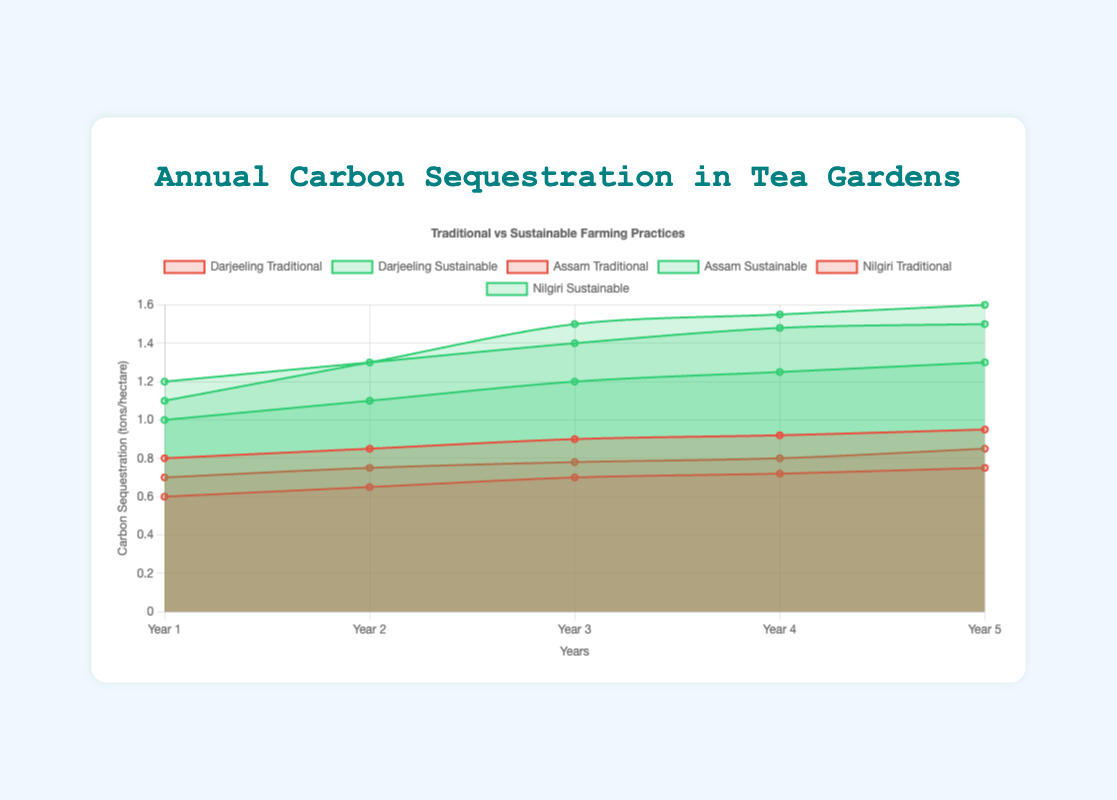What is the title of the chart? The title is displayed at the top of the chart, which reads "Annual Carbon Sequestration in Tea Gardens".
Answer: Annual Carbon Sequestration in Tea Gardens What does the y-axis represent? The label on the y-axis indicates it represents "Carbon Sequestration (tons/hectare)".
Answer: Carbon Sequestration (tons/hectare) How many years of data are displayed on the x-axis? The labels on the x-axis range from "Year 1" to "Year 5”.
Answer: 5 Which tea garden has the highest carbon sequestration in Year 5? By examining the lines for Year 5, the Darjeeling Sustainable tea garden reaches the highest carbon sequestration value of 1.6 tons/hectare.
Answer: Darjeeling Sustainable How does the sequestration rate of Nilgiri Traditional compare from Year 1 to Year 5? The chart shows that Nilgiri Traditional starts at 0.7 in Year 1 and increases to 0.85 in Year 5, indicating it rises over the years.
Answer: It increases What is the difference in carbon sequestration between Assam Sustainable and Traditional in Year 3? In Year 3, Assam Sustainable has 1.2 tons/hectare, and Assam Traditional has 0.7 tons/hectare. The difference is calculated as 1.2 - 0.7 = 0.5 tons/hectare.
Answer: 0.5 tons/hectare Which tea garden shows the most improvement in carbon sequestration from Year 1 to Year 2? Comparing the differences between Year 1 and Year 2 across all gardens, Darjeeling Sustainable shows the highest increase from 1.1 to 1.3 tons/hectare, an increase of 0.2 tons/hectare.
Answer: Darjeeling Sustainable What is the overall trend in carbon sequestration for traditional gardens? Observing the area chart, all traditional gardens (Darjeeling, Assam, Nilgiri) exhibit a gradual, almost linear increase in carbon sequestration rates over the years.
Answer: Gradual increase Compare the carbon sequestration rates of Darjeeling Sustainable in Year 2 and Year 4. In Year 2, Darjeeling Sustainable has 1.3 tons/hectare, and in Year 4, it has 1.55 tons/hectare. This shows an increase of 1.55 - 1.3 = 0.25 tons/hectare.
Answer: Increase of 0.25 tons/hectare 